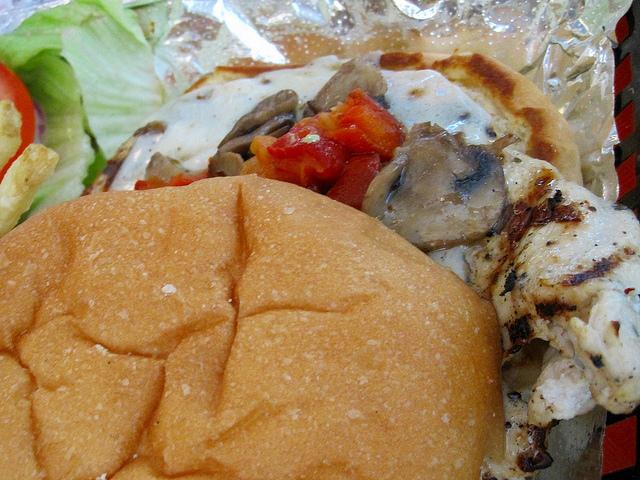What type of food is pictured?
Quick response, please. Hamburger. What wraps the sandwich?
Quick response, please. Foil. What dish is this?
Short answer required. Burger. What are the green things in the upper left of the picture?
Keep it brief. Lettuce. How many burgers on the plate?
Be succinct. 1. Is there a teapot in this picture?
Give a very brief answer. No. Is there a pickle on the plate?
Short answer required. No. Is the bun crunchier than the lettuce?
Concise answer only. No. What type of meat is in this sandwich?
Give a very brief answer. Chicken. 